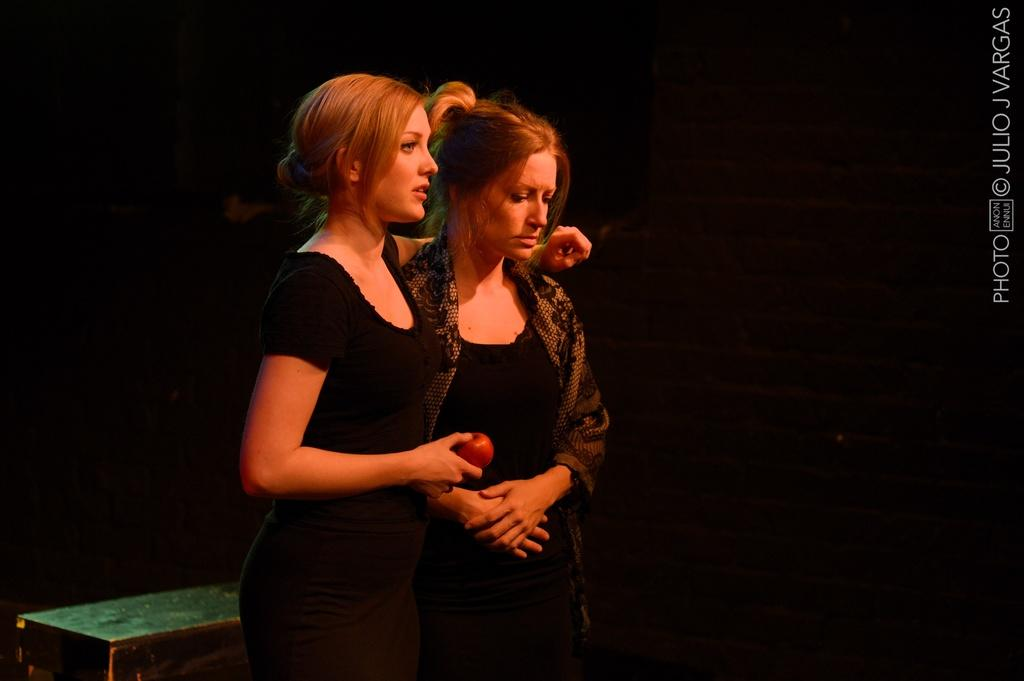How many people are in the image? There are two girls in the image. What is one of the girls holding? One of the girls is holding an apple. What color are the dresses worn by the girls? Both girls are wearing black color dresses. What type of wing can be seen on the girls in the image? There are no wings visible on the girls in the image. What type of rice is being prepared by the girls in the image? There is no rice or any cooking activity depicted in the image. 